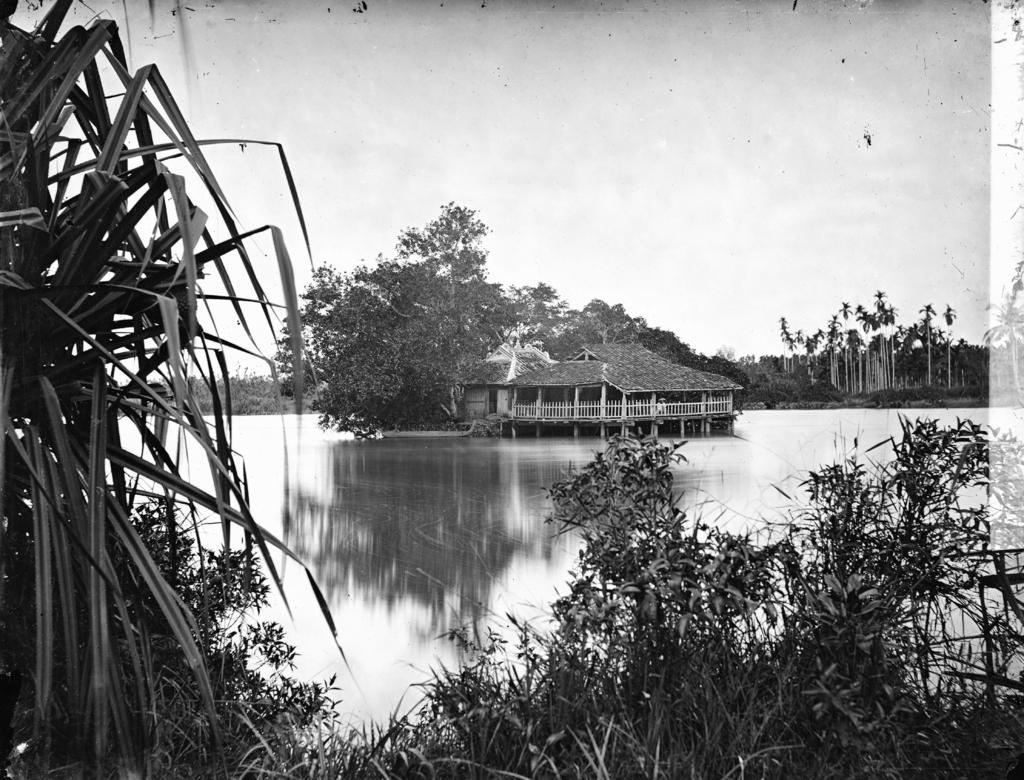Please provide a concise description of this image. In this image in the front there are plants. In the center there is water and on the water there is a house and there is a plant. In the background there are trees and the sky is cloudy. 